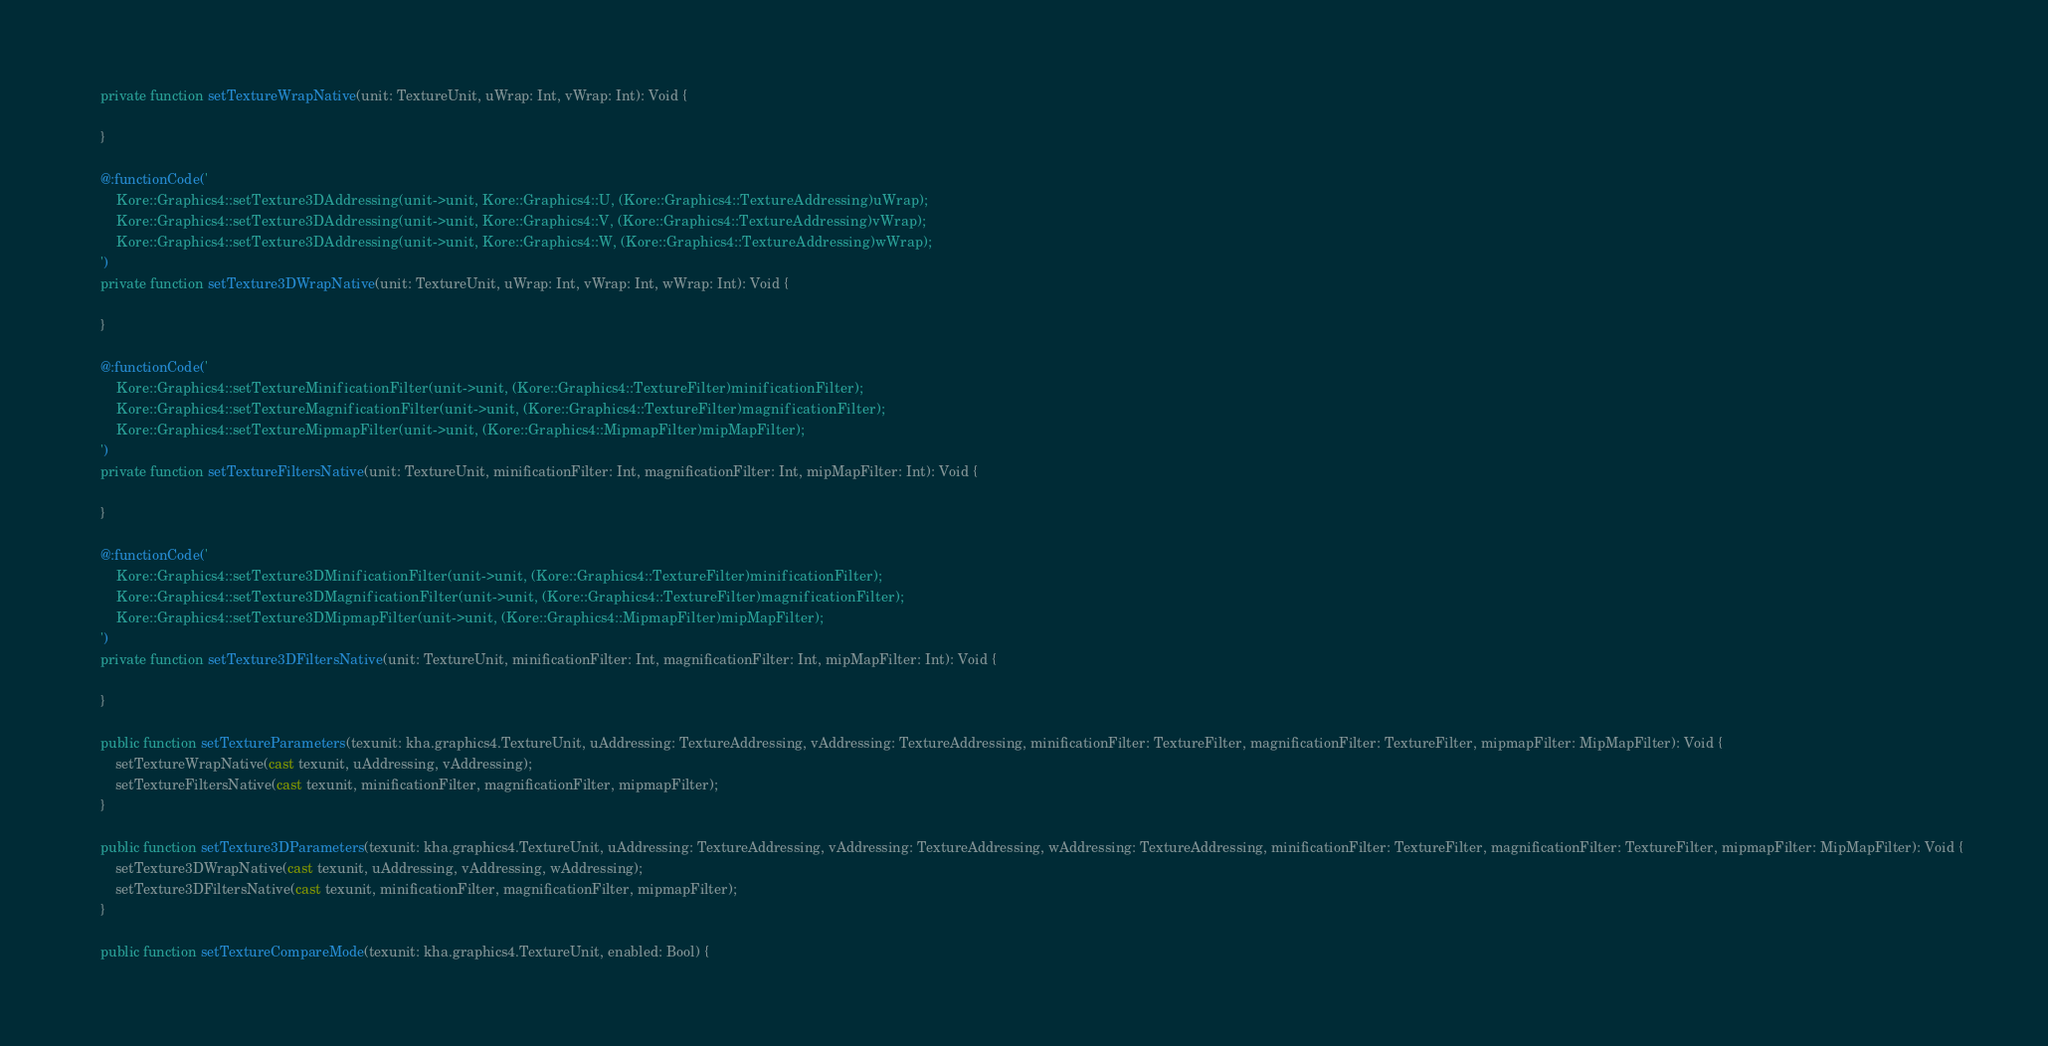<code> <loc_0><loc_0><loc_500><loc_500><_Haxe_>	private function setTextureWrapNative(unit: TextureUnit, uWrap: Int, vWrap: Int): Void {

	}

	@:functionCode('
		Kore::Graphics4::setTexture3DAddressing(unit->unit, Kore::Graphics4::U, (Kore::Graphics4::TextureAddressing)uWrap);
		Kore::Graphics4::setTexture3DAddressing(unit->unit, Kore::Graphics4::V, (Kore::Graphics4::TextureAddressing)vWrap);
		Kore::Graphics4::setTexture3DAddressing(unit->unit, Kore::Graphics4::W, (Kore::Graphics4::TextureAddressing)wWrap);
	')
	private function setTexture3DWrapNative(unit: TextureUnit, uWrap: Int, vWrap: Int, wWrap: Int): Void {

	}

	@:functionCode('
		Kore::Graphics4::setTextureMinificationFilter(unit->unit, (Kore::Graphics4::TextureFilter)minificationFilter);
		Kore::Graphics4::setTextureMagnificationFilter(unit->unit, (Kore::Graphics4::TextureFilter)magnificationFilter);
		Kore::Graphics4::setTextureMipmapFilter(unit->unit, (Kore::Graphics4::MipmapFilter)mipMapFilter);
	')
	private function setTextureFiltersNative(unit: TextureUnit, minificationFilter: Int, magnificationFilter: Int, mipMapFilter: Int): Void {

	}

	@:functionCode('
		Kore::Graphics4::setTexture3DMinificationFilter(unit->unit, (Kore::Graphics4::TextureFilter)minificationFilter);
		Kore::Graphics4::setTexture3DMagnificationFilter(unit->unit, (Kore::Graphics4::TextureFilter)magnificationFilter);
		Kore::Graphics4::setTexture3DMipmapFilter(unit->unit, (Kore::Graphics4::MipmapFilter)mipMapFilter);
	')
	private function setTexture3DFiltersNative(unit: TextureUnit, minificationFilter: Int, magnificationFilter: Int, mipMapFilter: Int): Void {

	}

	public function setTextureParameters(texunit: kha.graphics4.TextureUnit, uAddressing: TextureAddressing, vAddressing: TextureAddressing, minificationFilter: TextureFilter, magnificationFilter: TextureFilter, mipmapFilter: MipMapFilter): Void {
		setTextureWrapNative(cast texunit, uAddressing, vAddressing);
		setTextureFiltersNative(cast texunit, minificationFilter, magnificationFilter, mipmapFilter);
	}

	public function setTexture3DParameters(texunit: kha.graphics4.TextureUnit, uAddressing: TextureAddressing, vAddressing: TextureAddressing, wAddressing: TextureAddressing, minificationFilter: TextureFilter, magnificationFilter: TextureFilter, mipmapFilter: MipMapFilter): Void {
		setTexture3DWrapNative(cast texunit, uAddressing, vAddressing, wAddressing);
		setTexture3DFiltersNative(cast texunit, minificationFilter, magnificationFilter, mipmapFilter);
	}

	public function setTextureCompareMode(texunit: kha.graphics4.TextureUnit, enabled: Bool) {</code> 